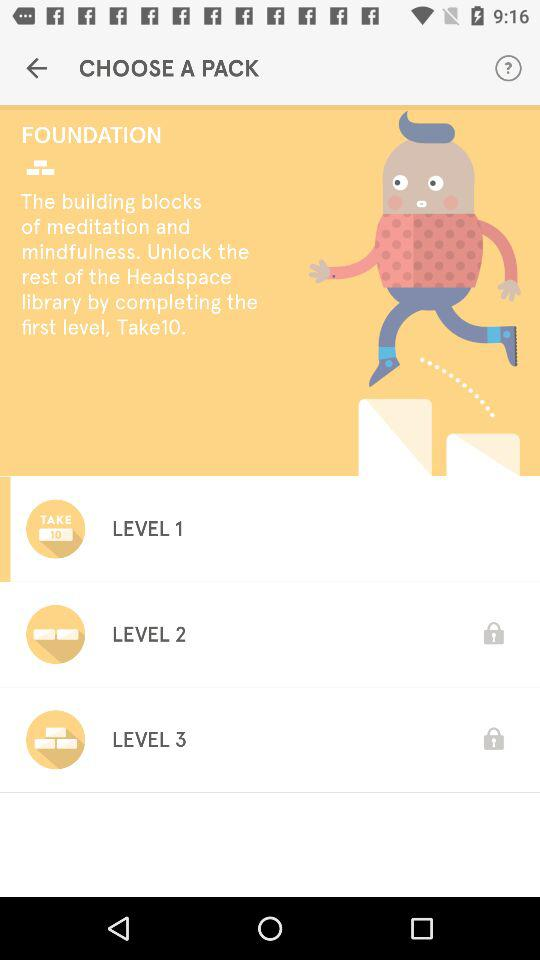What levels are locked? There are "LEVEL 2" and "LEVEL 3" locked. 